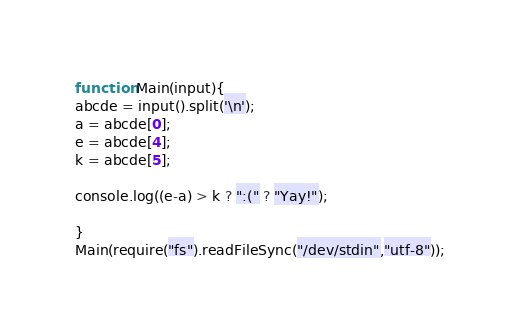<code> <loc_0><loc_0><loc_500><loc_500><_JavaScript_>function Main(input){
abcde = input().split('\n');
a = abcde[0];
e = abcde[4];
k = abcde[5];

console.log((e-a) > k ? ":(" ? "Yay!");

}
Main(require("fs").readFileSync("/dev/stdin","utf-8"));
</code> 